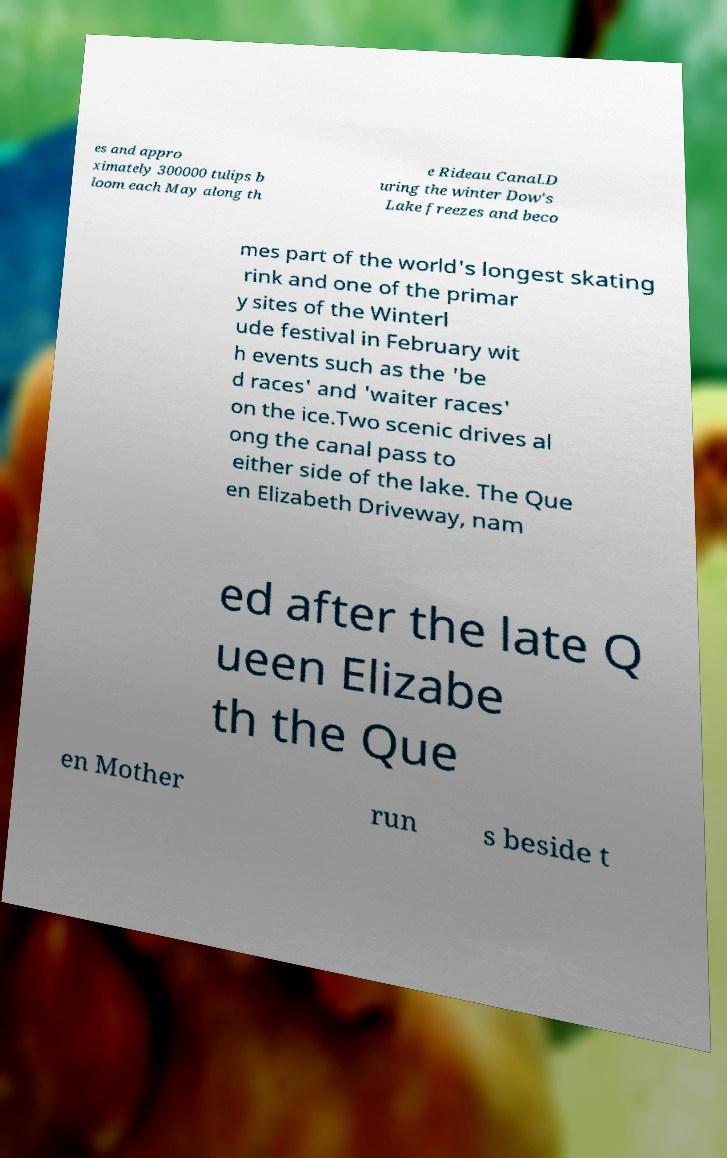Please read and relay the text visible in this image. What does it say? es and appro ximately 300000 tulips b loom each May along th e Rideau Canal.D uring the winter Dow's Lake freezes and beco mes part of the world's longest skating rink and one of the primar y sites of the Winterl ude festival in February wit h events such as the 'be d races' and 'waiter races' on the ice.Two scenic drives al ong the canal pass to either side of the lake. The Que en Elizabeth Driveway, nam ed after the late Q ueen Elizabe th the Que en Mother run s beside t 